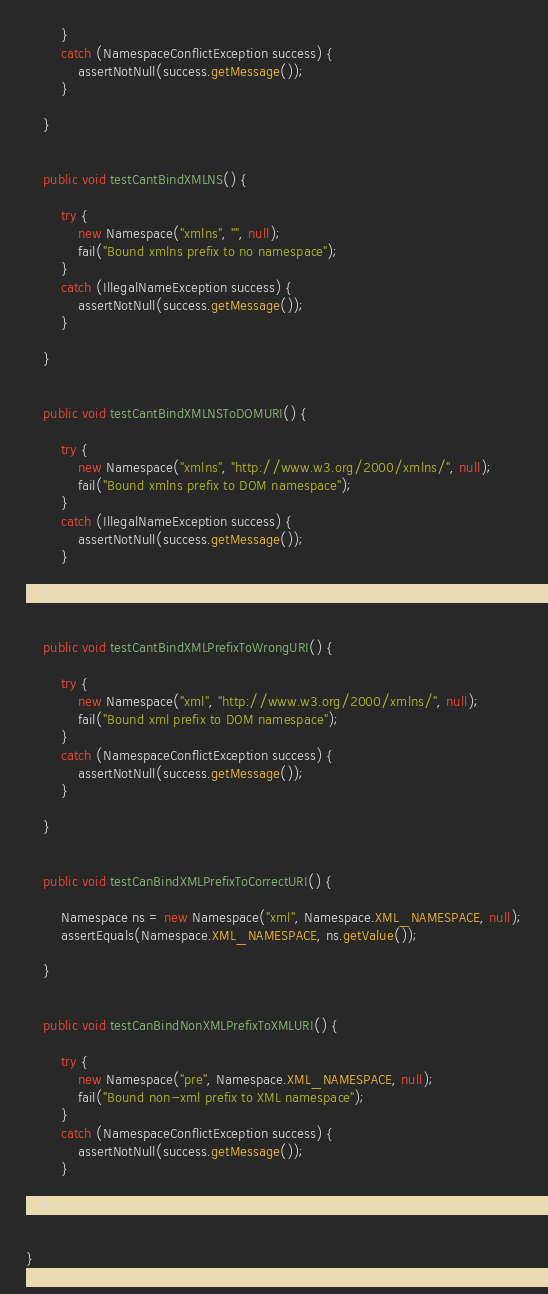<code> <loc_0><loc_0><loc_500><loc_500><_Java_>        }
        catch (NamespaceConflictException success) {
            assertNotNull(success.getMessage());
        }
        
    }

    
    public void testCantBindXMLNS() {
        
        try {
            new Namespace("xmlns", "", null);
            fail("Bound xmlns prefix to no namespace");
        }
        catch (IllegalNameException success) {
            assertNotNull(success.getMessage());
        }
        
    }

    
    public void testCantBindXMLNSToDOMURI() {
        
        try {
            new Namespace("xmlns", "http://www.w3.org/2000/xmlns/", null);
            fail("Bound xmlns prefix to DOM namespace");
        }
        catch (IllegalNameException success) {
            assertNotNull(success.getMessage());
        }
        
    }

    
    public void testCantBindXMLPrefixToWrongURI() {
        
        try {
            new Namespace("xml", "http://www.w3.org/2000/xmlns/", null);
            fail("Bound xml prefix to DOM namespace");
        }
        catch (NamespaceConflictException success) {
            assertNotNull(success.getMessage());
        }
        
    }

    
    public void testCanBindXMLPrefixToCorrectURI() {
        
        Namespace ns = new Namespace("xml", Namespace.XML_NAMESPACE, null);
        assertEquals(Namespace.XML_NAMESPACE, ns.getValue());
        
    }

    
    public void testCanBindNonXMLPrefixToXMLURI() {
        
        try {
            new Namespace("pre", Namespace.XML_NAMESPACE, null);
            fail("Bound non-xml prefix to XML namespace");
        }
        catch (NamespaceConflictException success) {
            assertNotNull(success.getMessage());
        }
        
    }

    
}
</code> 